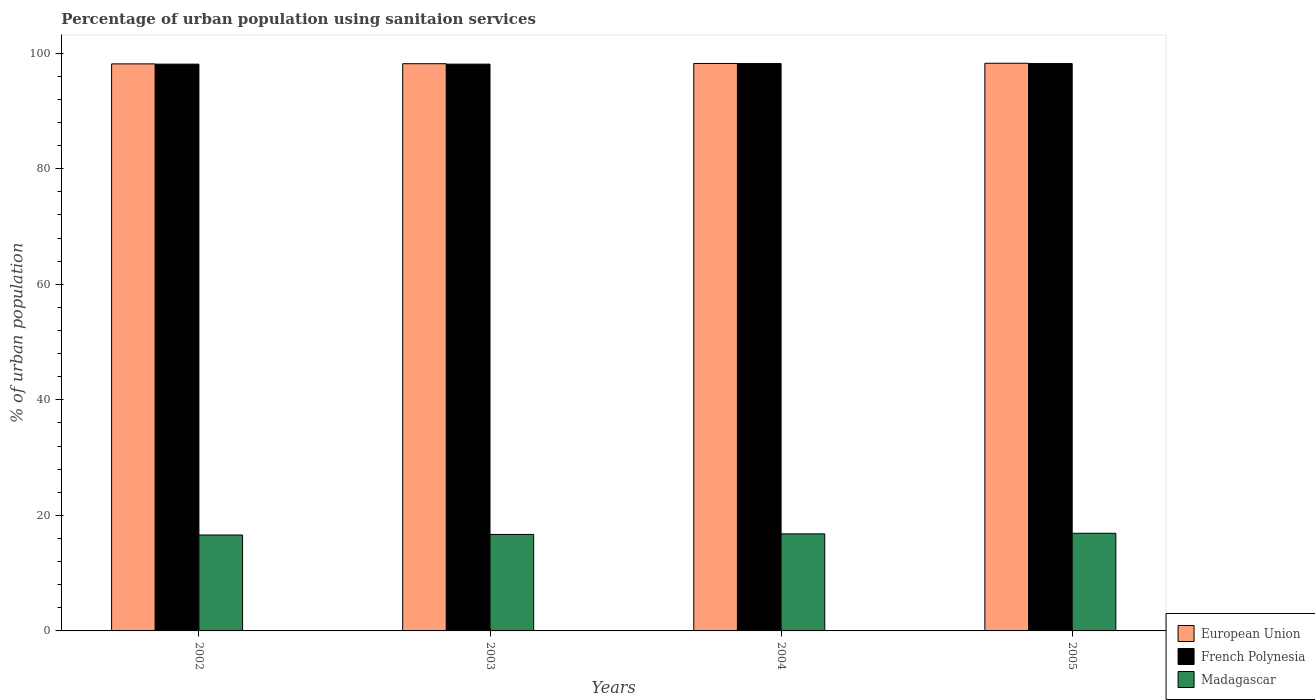How many different coloured bars are there?
Keep it short and to the point. 3. How many groups of bars are there?
Keep it short and to the point. 4. Are the number of bars per tick equal to the number of legend labels?
Provide a short and direct response. Yes. Are the number of bars on each tick of the X-axis equal?
Provide a short and direct response. Yes. What is the label of the 4th group of bars from the left?
Offer a very short reply. 2005. In how many cases, is the number of bars for a given year not equal to the number of legend labels?
Your answer should be very brief. 0. What is the percentage of urban population using sanitaion services in European Union in 2003?
Give a very brief answer. 98.17. Across all years, what is the maximum percentage of urban population using sanitaion services in French Polynesia?
Provide a short and direct response. 98.2. Across all years, what is the minimum percentage of urban population using sanitaion services in Madagascar?
Give a very brief answer. 16.6. In which year was the percentage of urban population using sanitaion services in European Union maximum?
Ensure brevity in your answer.  2005. In which year was the percentage of urban population using sanitaion services in Madagascar minimum?
Offer a very short reply. 2002. What is the total percentage of urban population using sanitaion services in Madagascar in the graph?
Offer a terse response. 67. What is the difference between the percentage of urban population using sanitaion services in European Union in 2004 and that in 2005?
Provide a short and direct response. -0.04. What is the difference between the percentage of urban population using sanitaion services in French Polynesia in 2003 and the percentage of urban population using sanitaion services in European Union in 2005?
Keep it short and to the point. -0.15. What is the average percentage of urban population using sanitaion services in European Union per year?
Your answer should be very brief. 98.2. In the year 2002, what is the difference between the percentage of urban population using sanitaion services in French Polynesia and percentage of urban population using sanitaion services in Madagascar?
Provide a short and direct response. 81.5. What is the ratio of the percentage of urban population using sanitaion services in Madagascar in 2004 to that in 2005?
Your response must be concise. 0.99. What is the difference between the highest and the second highest percentage of urban population using sanitaion services in European Union?
Make the answer very short. 0.04. What is the difference between the highest and the lowest percentage of urban population using sanitaion services in Madagascar?
Keep it short and to the point. 0.3. In how many years, is the percentage of urban population using sanitaion services in European Union greater than the average percentage of urban population using sanitaion services in European Union taken over all years?
Keep it short and to the point. 2. Is the sum of the percentage of urban population using sanitaion services in Madagascar in 2003 and 2004 greater than the maximum percentage of urban population using sanitaion services in European Union across all years?
Your answer should be compact. No. What does the 3rd bar from the left in 2005 represents?
Your answer should be compact. Madagascar. What does the 1st bar from the right in 2003 represents?
Provide a short and direct response. Madagascar. Is it the case that in every year, the sum of the percentage of urban population using sanitaion services in Madagascar and percentage of urban population using sanitaion services in French Polynesia is greater than the percentage of urban population using sanitaion services in European Union?
Your answer should be very brief. Yes. How many bars are there?
Provide a short and direct response. 12. Are all the bars in the graph horizontal?
Ensure brevity in your answer.  No. Does the graph contain any zero values?
Make the answer very short. No. Does the graph contain grids?
Your response must be concise. No. How many legend labels are there?
Offer a very short reply. 3. How are the legend labels stacked?
Provide a short and direct response. Vertical. What is the title of the graph?
Provide a short and direct response. Percentage of urban population using sanitaion services. What is the label or title of the Y-axis?
Provide a succinct answer. % of urban population. What is the % of urban population in European Union in 2002?
Your response must be concise. 98.14. What is the % of urban population in French Polynesia in 2002?
Give a very brief answer. 98.1. What is the % of urban population in Madagascar in 2002?
Ensure brevity in your answer.  16.6. What is the % of urban population in European Union in 2003?
Offer a very short reply. 98.17. What is the % of urban population of French Polynesia in 2003?
Your response must be concise. 98.1. What is the % of urban population of Madagascar in 2003?
Ensure brevity in your answer.  16.7. What is the % of urban population of European Union in 2004?
Provide a short and direct response. 98.21. What is the % of urban population in French Polynesia in 2004?
Your answer should be very brief. 98.2. What is the % of urban population in European Union in 2005?
Your answer should be very brief. 98.25. What is the % of urban population in French Polynesia in 2005?
Keep it short and to the point. 98.2. Across all years, what is the maximum % of urban population in European Union?
Make the answer very short. 98.25. Across all years, what is the maximum % of urban population of French Polynesia?
Give a very brief answer. 98.2. Across all years, what is the minimum % of urban population of European Union?
Make the answer very short. 98.14. Across all years, what is the minimum % of urban population in French Polynesia?
Keep it short and to the point. 98.1. What is the total % of urban population of European Union in the graph?
Keep it short and to the point. 392.78. What is the total % of urban population of French Polynesia in the graph?
Make the answer very short. 392.6. What is the difference between the % of urban population of European Union in 2002 and that in 2003?
Your answer should be very brief. -0.03. What is the difference between the % of urban population of European Union in 2002 and that in 2004?
Offer a terse response. -0.07. What is the difference between the % of urban population of Madagascar in 2002 and that in 2004?
Your answer should be compact. -0.2. What is the difference between the % of urban population in European Union in 2002 and that in 2005?
Offer a very short reply. -0.11. What is the difference between the % of urban population of Madagascar in 2002 and that in 2005?
Keep it short and to the point. -0.3. What is the difference between the % of urban population of European Union in 2003 and that in 2004?
Provide a short and direct response. -0.04. What is the difference between the % of urban population of European Union in 2003 and that in 2005?
Offer a terse response. -0.08. What is the difference between the % of urban population in French Polynesia in 2003 and that in 2005?
Provide a succinct answer. -0.1. What is the difference between the % of urban population of Madagascar in 2003 and that in 2005?
Offer a terse response. -0.2. What is the difference between the % of urban population of European Union in 2004 and that in 2005?
Provide a short and direct response. -0.04. What is the difference between the % of urban population of French Polynesia in 2004 and that in 2005?
Keep it short and to the point. 0. What is the difference between the % of urban population in European Union in 2002 and the % of urban population in French Polynesia in 2003?
Offer a terse response. 0.04. What is the difference between the % of urban population of European Union in 2002 and the % of urban population of Madagascar in 2003?
Your response must be concise. 81.44. What is the difference between the % of urban population of French Polynesia in 2002 and the % of urban population of Madagascar in 2003?
Provide a short and direct response. 81.4. What is the difference between the % of urban population of European Union in 2002 and the % of urban population of French Polynesia in 2004?
Your answer should be very brief. -0.06. What is the difference between the % of urban population in European Union in 2002 and the % of urban population in Madagascar in 2004?
Your response must be concise. 81.34. What is the difference between the % of urban population in French Polynesia in 2002 and the % of urban population in Madagascar in 2004?
Your response must be concise. 81.3. What is the difference between the % of urban population in European Union in 2002 and the % of urban population in French Polynesia in 2005?
Offer a very short reply. -0.06. What is the difference between the % of urban population in European Union in 2002 and the % of urban population in Madagascar in 2005?
Provide a succinct answer. 81.24. What is the difference between the % of urban population of French Polynesia in 2002 and the % of urban population of Madagascar in 2005?
Ensure brevity in your answer.  81.2. What is the difference between the % of urban population of European Union in 2003 and the % of urban population of French Polynesia in 2004?
Make the answer very short. -0.03. What is the difference between the % of urban population in European Union in 2003 and the % of urban population in Madagascar in 2004?
Provide a succinct answer. 81.37. What is the difference between the % of urban population in French Polynesia in 2003 and the % of urban population in Madagascar in 2004?
Your answer should be very brief. 81.3. What is the difference between the % of urban population of European Union in 2003 and the % of urban population of French Polynesia in 2005?
Keep it short and to the point. -0.03. What is the difference between the % of urban population in European Union in 2003 and the % of urban population in Madagascar in 2005?
Your response must be concise. 81.27. What is the difference between the % of urban population of French Polynesia in 2003 and the % of urban population of Madagascar in 2005?
Give a very brief answer. 81.2. What is the difference between the % of urban population of European Union in 2004 and the % of urban population of French Polynesia in 2005?
Provide a short and direct response. 0.01. What is the difference between the % of urban population of European Union in 2004 and the % of urban population of Madagascar in 2005?
Give a very brief answer. 81.31. What is the difference between the % of urban population of French Polynesia in 2004 and the % of urban population of Madagascar in 2005?
Ensure brevity in your answer.  81.3. What is the average % of urban population in European Union per year?
Your answer should be very brief. 98.2. What is the average % of urban population of French Polynesia per year?
Your answer should be compact. 98.15. What is the average % of urban population of Madagascar per year?
Keep it short and to the point. 16.75. In the year 2002, what is the difference between the % of urban population in European Union and % of urban population in French Polynesia?
Your answer should be very brief. 0.04. In the year 2002, what is the difference between the % of urban population of European Union and % of urban population of Madagascar?
Provide a succinct answer. 81.54. In the year 2002, what is the difference between the % of urban population of French Polynesia and % of urban population of Madagascar?
Make the answer very short. 81.5. In the year 2003, what is the difference between the % of urban population of European Union and % of urban population of French Polynesia?
Your answer should be compact. 0.07. In the year 2003, what is the difference between the % of urban population in European Union and % of urban population in Madagascar?
Your response must be concise. 81.47. In the year 2003, what is the difference between the % of urban population in French Polynesia and % of urban population in Madagascar?
Keep it short and to the point. 81.4. In the year 2004, what is the difference between the % of urban population in European Union and % of urban population in French Polynesia?
Provide a short and direct response. 0.01. In the year 2004, what is the difference between the % of urban population of European Union and % of urban population of Madagascar?
Give a very brief answer. 81.41. In the year 2004, what is the difference between the % of urban population of French Polynesia and % of urban population of Madagascar?
Your answer should be very brief. 81.4. In the year 2005, what is the difference between the % of urban population in European Union and % of urban population in French Polynesia?
Your answer should be compact. 0.05. In the year 2005, what is the difference between the % of urban population in European Union and % of urban population in Madagascar?
Offer a terse response. 81.35. In the year 2005, what is the difference between the % of urban population of French Polynesia and % of urban population of Madagascar?
Make the answer very short. 81.3. What is the ratio of the % of urban population in European Union in 2002 to that in 2003?
Your answer should be very brief. 1. What is the ratio of the % of urban population of French Polynesia in 2002 to that in 2003?
Your answer should be very brief. 1. What is the ratio of the % of urban population in Madagascar in 2002 to that in 2003?
Keep it short and to the point. 0.99. What is the ratio of the % of urban population of French Polynesia in 2002 to that in 2004?
Ensure brevity in your answer.  1. What is the ratio of the % of urban population of Madagascar in 2002 to that in 2004?
Keep it short and to the point. 0.99. What is the ratio of the % of urban population in European Union in 2002 to that in 2005?
Your response must be concise. 1. What is the ratio of the % of urban population of French Polynesia in 2002 to that in 2005?
Offer a very short reply. 1. What is the ratio of the % of urban population in Madagascar in 2002 to that in 2005?
Your answer should be compact. 0.98. What is the ratio of the % of urban population in European Union in 2004 to that in 2005?
Your response must be concise. 1. What is the difference between the highest and the second highest % of urban population in European Union?
Offer a terse response. 0.04. What is the difference between the highest and the second highest % of urban population of French Polynesia?
Offer a very short reply. 0. What is the difference between the highest and the lowest % of urban population in European Union?
Make the answer very short. 0.11. 